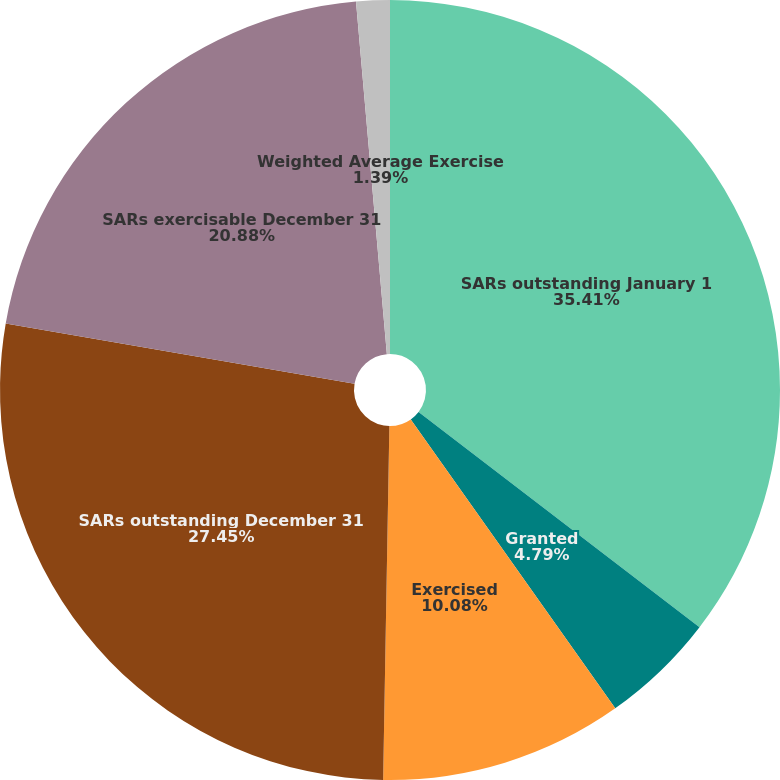<chart> <loc_0><loc_0><loc_500><loc_500><pie_chart><fcel>SARs outstanding January 1<fcel>Granted<fcel>Exercised<fcel>SARs outstanding December 31<fcel>SARs exercisable December 31<fcel>Weighted Average Exercise<nl><fcel>35.41%<fcel>4.79%<fcel>10.08%<fcel>27.45%<fcel>20.88%<fcel>1.39%<nl></chart> 